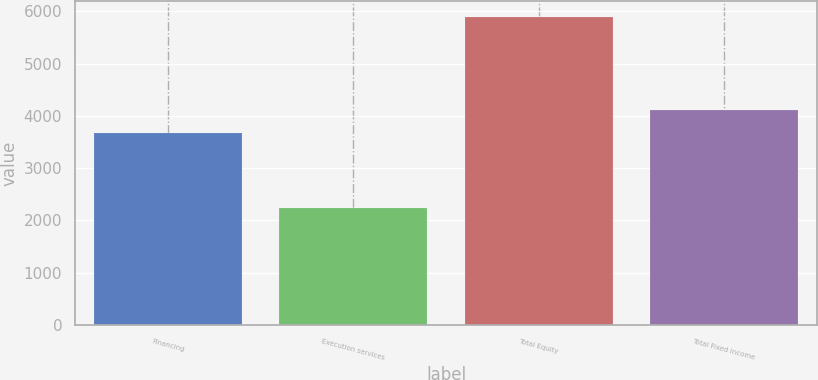<chart> <loc_0><loc_0><loc_500><loc_500><bar_chart><fcel>Financing<fcel>Execution services<fcel>Total Equity<fcel>Total Fixed income<nl><fcel>3668<fcel>2231<fcel>5899<fcel>4115<nl></chart> 